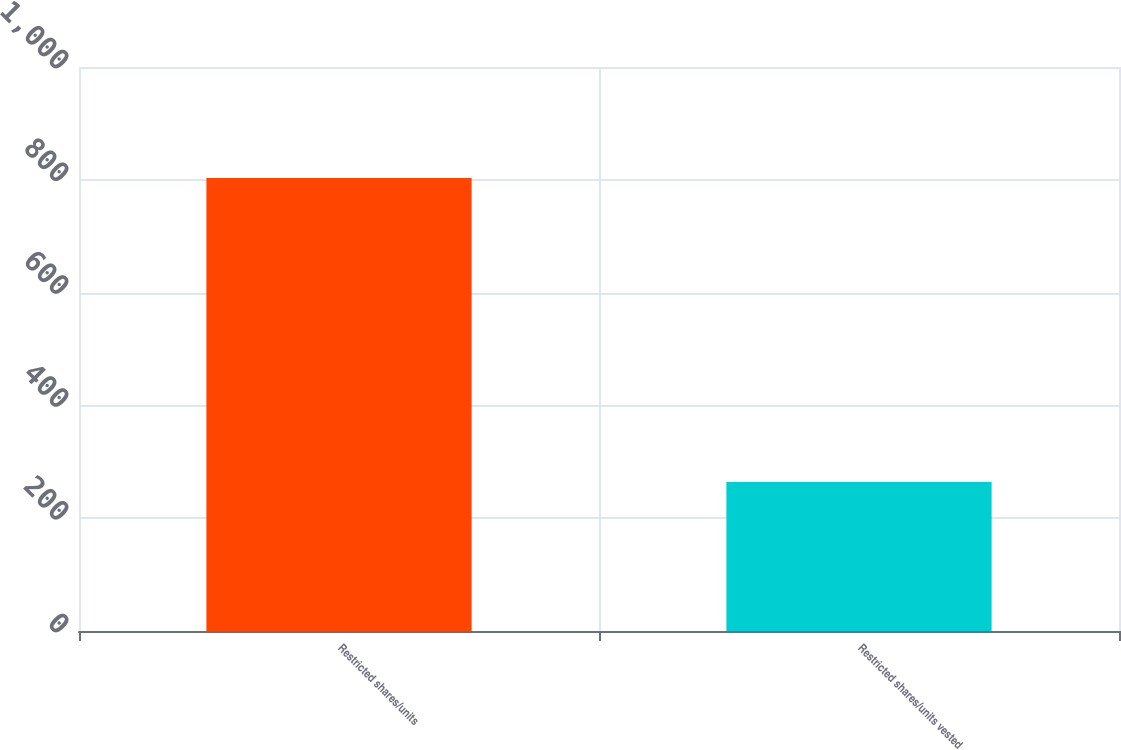Convert chart to OTSL. <chart><loc_0><loc_0><loc_500><loc_500><bar_chart><fcel>Restricted shares/units<fcel>Restricted shares/units vested<nl><fcel>803<fcel>264<nl></chart> 